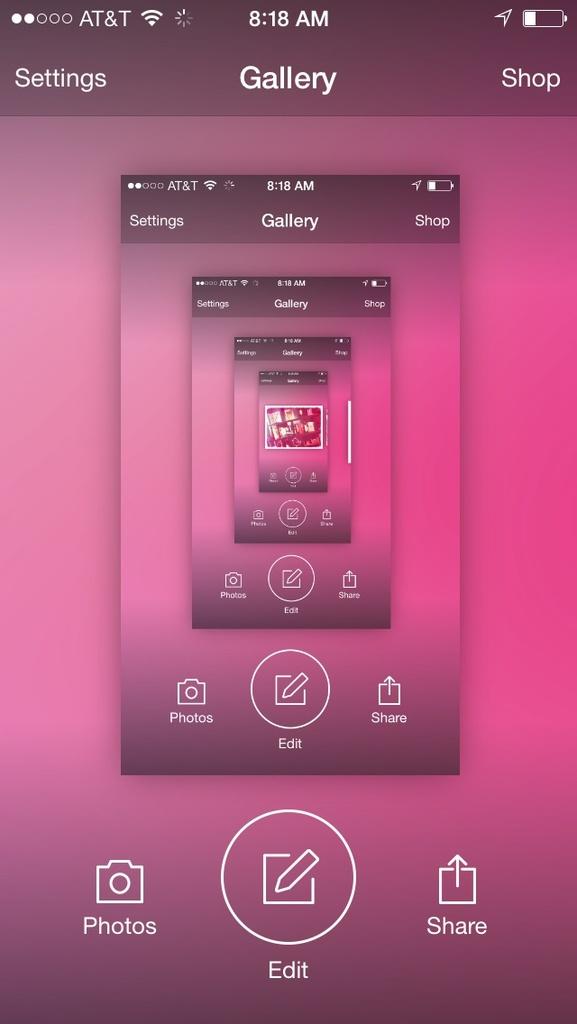What app is displayed?
Your answer should be compact. Gallery. What is the button in the middle on the bottom?
Provide a short and direct response. Edit. 